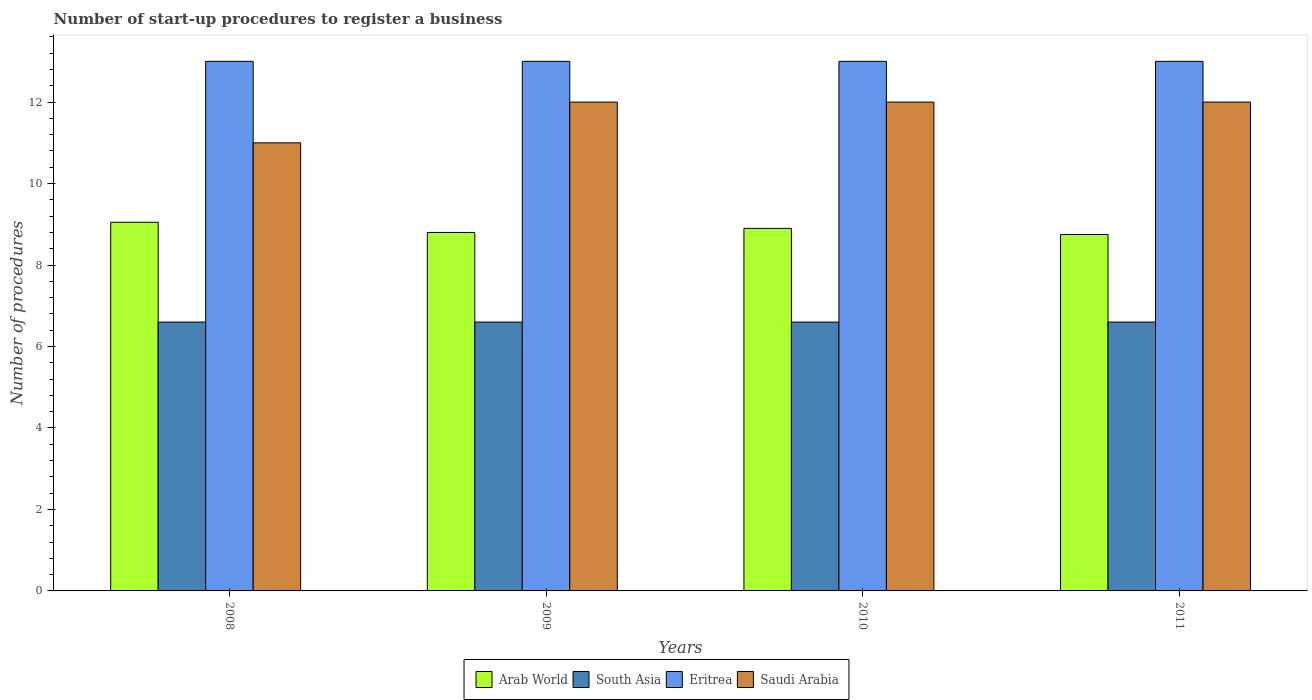How many different coloured bars are there?
Give a very brief answer. 4. How many bars are there on the 2nd tick from the left?
Keep it short and to the point. 4. How many bars are there on the 3rd tick from the right?
Provide a succinct answer. 4. What is the number of procedures required to register a business in Eritrea in 2011?
Provide a short and direct response. 13. Across all years, what is the maximum number of procedures required to register a business in Arab World?
Keep it short and to the point. 9.05. Across all years, what is the minimum number of procedures required to register a business in Eritrea?
Keep it short and to the point. 13. In which year was the number of procedures required to register a business in Eritrea maximum?
Provide a succinct answer. 2008. What is the total number of procedures required to register a business in South Asia in the graph?
Provide a short and direct response. 26.4. What is the difference between the number of procedures required to register a business in Eritrea in 2008 and that in 2011?
Provide a succinct answer. 0. What is the difference between the number of procedures required to register a business in South Asia in 2008 and the number of procedures required to register a business in Eritrea in 2010?
Offer a very short reply. -6.4. In the year 2010, what is the difference between the number of procedures required to register a business in Eritrea and number of procedures required to register a business in Arab World?
Provide a succinct answer. 4.1. What is the ratio of the number of procedures required to register a business in Saudi Arabia in 2008 to that in 2011?
Offer a terse response. 0.92. Is the number of procedures required to register a business in Saudi Arabia in 2010 less than that in 2011?
Ensure brevity in your answer.  No. Is the difference between the number of procedures required to register a business in Eritrea in 2009 and 2010 greater than the difference between the number of procedures required to register a business in Arab World in 2009 and 2010?
Offer a very short reply. Yes. What is the difference between the highest and the second highest number of procedures required to register a business in Saudi Arabia?
Offer a very short reply. 0. Is the sum of the number of procedures required to register a business in Arab World in 2010 and 2011 greater than the maximum number of procedures required to register a business in Saudi Arabia across all years?
Provide a succinct answer. Yes. What does the 2nd bar from the left in 2011 represents?
Your response must be concise. South Asia. What does the 2nd bar from the right in 2010 represents?
Give a very brief answer. Eritrea. Is it the case that in every year, the sum of the number of procedures required to register a business in Arab World and number of procedures required to register a business in Eritrea is greater than the number of procedures required to register a business in Saudi Arabia?
Offer a terse response. Yes. How many bars are there?
Your answer should be very brief. 16. What is the difference between two consecutive major ticks on the Y-axis?
Give a very brief answer. 2. Where does the legend appear in the graph?
Your answer should be compact. Bottom center. How are the legend labels stacked?
Offer a very short reply. Horizontal. What is the title of the graph?
Offer a terse response. Number of start-up procedures to register a business. Does "Equatorial Guinea" appear as one of the legend labels in the graph?
Provide a short and direct response. No. What is the label or title of the Y-axis?
Your answer should be very brief. Number of procedures. What is the Number of procedures of Arab World in 2008?
Your answer should be very brief. 9.05. What is the Number of procedures in Eritrea in 2008?
Your answer should be very brief. 13. What is the Number of procedures in Arab World in 2009?
Give a very brief answer. 8.8. What is the Number of procedures in South Asia in 2009?
Give a very brief answer. 6.6. What is the Number of procedures in South Asia in 2010?
Provide a succinct answer. 6.6. What is the Number of procedures in Eritrea in 2010?
Give a very brief answer. 13. What is the Number of procedures of Saudi Arabia in 2010?
Offer a very short reply. 12. What is the Number of procedures of Arab World in 2011?
Your answer should be very brief. 8.75. What is the Number of procedures of South Asia in 2011?
Give a very brief answer. 6.6. Across all years, what is the maximum Number of procedures of Arab World?
Your response must be concise. 9.05. Across all years, what is the maximum Number of procedures of South Asia?
Provide a succinct answer. 6.6. Across all years, what is the maximum Number of procedures in Eritrea?
Your response must be concise. 13. Across all years, what is the minimum Number of procedures in Arab World?
Keep it short and to the point. 8.75. Across all years, what is the minimum Number of procedures of South Asia?
Your response must be concise. 6.6. Across all years, what is the minimum Number of procedures of Eritrea?
Offer a terse response. 13. What is the total Number of procedures of Arab World in the graph?
Provide a short and direct response. 35.5. What is the total Number of procedures of South Asia in the graph?
Provide a short and direct response. 26.4. What is the difference between the Number of procedures in South Asia in 2008 and that in 2009?
Your answer should be very brief. 0. What is the difference between the Number of procedures of Saudi Arabia in 2008 and that in 2009?
Ensure brevity in your answer.  -1. What is the difference between the Number of procedures of South Asia in 2008 and that in 2010?
Provide a succinct answer. 0. What is the difference between the Number of procedures of Arab World in 2008 and that in 2011?
Your answer should be compact. 0.3. What is the difference between the Number of procedures in South Asia in 2008 and that in 2011?
Give a very brief answer. 0. What is the difference between the Number of procedures of Eritrea in 2008 and that in 2011?
Offer a very short reply. 0. What is the difference between the Number of procedures in Arab World in 2009 and that in 2010?
Give a very brief answer. -0.1. What is the difference between the Number of procedures of South Asia in 2009 and that in 2010?
Make the answer very short. 0. What is the difference between the Number of procedures in Eritrea in 2009 and that in 2010?
Your response must be concise. 0. What is the difference between the Number of procedures in South Asia in 2009 and that in 2011?
Provide a succinct answer. 0. What is the difference between the Number of procedures of Eritrea in 2009 and that in 2011?
Your response must be concise. 0. What is the difference between the Number of procedures of Saudi Arabia in 2009 and that in 2011?
Provide a succinct answer. 0. What is the difference between the Number of procedures of South Asia in 2010 and that in 2011?
Ensure brevity in your answer.  0. What is the difference between the Number of procedures in Eritrea in 2010 and that in 2011?
Offer a very short reply. 0. What is the difference between the Number of procedures in Arab World in 2008 and the Number of procedures in South Asia in 2009?
Offer a terse response. 2.45. What is the difference between the Number of procedures in Arab World in 2008 and the Number of procedures in Eritrea in 2009?
Make the answer very short. -3.95. What is the difference between the Number of procedures of Arab World in 2008 and the Number of procedures of Saudi Arabia in 2009?
Offer a terse response. -2.95. What is the difference between the Number of procedures in South Asia in 2008 and the Number of procedures in Eritrea in 2009?
Your response must be concise. -6.4. What is the difference between the Number of procedures in Arab World in 2008 and the Number of procedures in South Asia in 2010?
Make the answer very short. 2.45. What is the difference between the Number of procedures of Arab World in 2008 and the Number of procedures of Eritrea in 2010?
Your response must be concise. -3.95. What is the difference between the Number of procedures of Arab World in 2008 and the Number of procedures of Saudi Arabia in 2010?
Your answer should be compact. -2.95. What is the difference between the Number of procedures of South Asia in 2008 and the Number of procedures of Eritrea in 2010?
Provide a succinct answer. -6.4. What is the difference between the Number of procedures of South Asia in 2008 and the Number of procedures of Saudi Arabia in 2010?
Provide a succinct answer. -5.4. What is the difference between the Number of procedures of Arab World in 2008 and the Number of procedures of South Asia in 2011?
Give a very brief answer. 2.45. What is the difference between the Number of procedures in Arab World in 2008 and the Number of procedures in Eritrea in 2011?
Offer a very short reply. -3.95. What is the difference between the Number of procedures in Arab World in 2008 and the Number of procedures in Saudi Arabia in 2011?
Provide a succinct answer. -2.95. What is the difference between the Number of procedures in South Asia in 2008 and the Number of procedures in Eritrea in 2011?
Make the answer very short. -6.4. What is the difference between the Number of procedures in Eritrea in 2008 and the Number of procedures in Saudi Arabia in 2011?
Offer a very short reply. 1. What is the difference between the Number of procedures in Arab World in 2009 and the Number of procedures in South Asia in 2010?
Provide a succinct answer. 2.2. What is the difference between the Number of procedures of Arab World in 2009 and the Number of procedures of Saudi Arabia in 2010?
Provide a succinct answer. -3.2. What is the difference between the Number of procedures of South Asia in 2009 and the Number of procedures of Eritrea in 2010?
Ensure brevity in your answer.  -6.4. What is the difference between the Number of procedures in Arab World in 2009 and the Number of procedures in South Asia in 2011?
Ensure brevity in your answer.  2.2. What is the difference between the Number of procedures of South Asia in 2009 and the Number of procedures of Saudi Arabia in 2011?
Your answer should be very brief. -5.4. What is the average Number of procedures of Arab World per year?
Keep it short and to the point. 8.88. What is the average Number of procedures in Saudi Arabia per year?
Keep it short and to the point. 11.75. In the year 2008, what is the difference between the Number of procedures in Arab World and Number of procedures in South Asia?
Make the answer very short. 2.45. In the year 2008, what is the difference between the Number of procedures in Arab World and Number of procedures in Eritrea?
Your answer should be compact. -3.95. In the year 2008, what is the difference between the Number of procedures of Arab World and Number of procedures of Saudi Arabia?
Provide a succinct answer. -1.95. In the year 2008, what is the difference between the Number of procedures of South Asia and Number of procedures of Eritrea?
Your answer should be compact. -6.4. In the year 2008, what is the difference between the Number of procedures in South Asia and Number of procedures in Saudi Arabia?
Give a very brief answer. -4.4. In the year 2009, what is the difference between the Number of procedures in Arab World and Number of procedures in South Asia?
Provide a short and direct response. 2.2. In the year 2009, what is the difference between the Number of procedures of Arab World and Number of procedures of Eritrea?
Ensure brevity in your answer.  -4.2. In the year 2009, what is the difference between the Number of procedures of Arab World and Number of procedures of Saudi Arabia?
Ensure brevity in your answer.  -3.2. In the year 2009, what is the difference between the Number of procedures of South Asia and Number of procedures of Eritrea?
Offer a terse response. -6.4. In the year 2009, what is the difference between the Number of procedures of South Asia and Number of procedures of Saudi Arabia?
Your answer should be very brief. -5.4. In the year 2009, what is the difference between the Number of procedures of Eritrea and Number of procedures of Saudi Arabia?
Make the answer very short. 1. In the year 2010, what is the difference between the Number of procedures of Arab World and Number of procedures of South Asia?
Provide a succinct answer. 2.3. In the year 2010, what is the difference between the Number of procedures in Arab World and Number of procedures in Saudi Arabia?
Keep it short and to the point. -3.1. In the year 2010, what is the difference between the Number of procedures in South Asia and Number of procedures in Eritrea?
Your answer should be compact. -6.4. In the year 2010, what is the difference between the Number of procedures in Eritrea and Number of procedures in Saudi Arabia?
Keep it short and to the point. 1. In the year 2011, what is the difference between the Number of procedures of Arab World and Number of procedures of South Asia?
Keep it short and to the point. 2.15. In the year 2011, what is the difference between the Number of procedures in Arab World and Number of procedures in Eritrea?
Your response must be concise. -4.25. In the year 2011, what is the difference between the Number of procedures in Arab World and Number of procedures in Saudi Arabia?
Provide a short and direct response. -3.25. In the year 2011, what is the difference between the Number of procedures of South Asia and Number of procedures of Eritrea?
Give a very brief answer. -6.4. In the year 2011, what is the difference between the Number of procedures in Eritrea and Number of procedures in Saudi Arabia?
Offer a very short reply. 1. What is the ratio of the Number of procedures of Arab World in 2008 to that in 2009?
Provide a short and direct response. 1.03. What is the ratio of the Number of procedures in South Asia in 2008 to that in 2009?
Provide a short and direct response. 1. What is the ratio of the Number of procedures of Arab World in 2008 to that in 2010?
Make the answer very short. 1.02. What is the ratio of the Number of procedures in South Asia in 2008 to that in 2010?
Offer a terse response. 1. What is the ratio of the Number of procedures of Eritrea in 2008 to that in 2010?
Ensure brevity in your answer.  1. What is the ratio of the Number of procedures in Saudi Arabia in 2008 to that in 2010?
Make the answer very short. 0.92. What is the ratio of the Number of procedures of Arab World in 2008 to that in 2011?
Make the answer very short. 1.03. What is the ratio of the Number of procedures of South Asia in 2008 to that in 2011?
Ensure brevity in your answer.  1. What is the ratio of the Number of procedures in Arab World in 2009 to that in 2010?
Keep it short and to the point. 0.99. What is the ratio of the Number of procedures of Arab World in 2009 to that in 2011?
Make the answer very short. 1.01. What is the ratio of the Number of procedures in Arab World in 2010 to that in 2011?
Your response must be concise. 1.02. What is the ratio of the Number of procedures in South Asia in 2010 to that in 2011?
Ensure brevity in your answer.  1. What is the difference between the highest and the second highest Number of procedures of South Asia?
Provide a short and direct response. 0. 